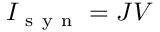<formula> <loc_0><loc_0><loc_500><loc_500>I _ { s y n } = J V</formula> 